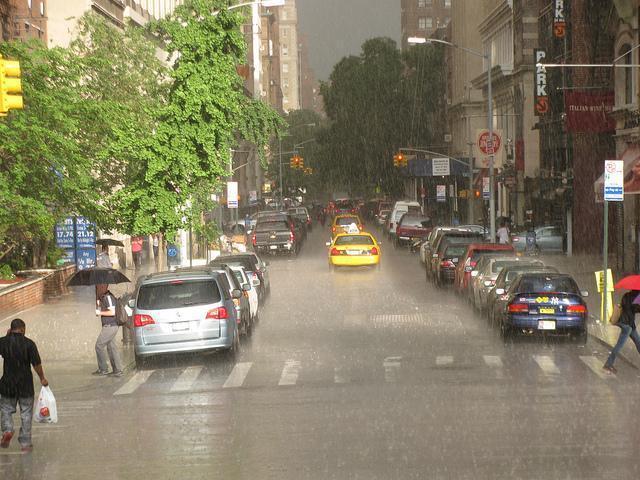How many people have an umbrella?
Give a very brief answer. 2. How many cars can be seen?
Give a very brief answer. 3. 